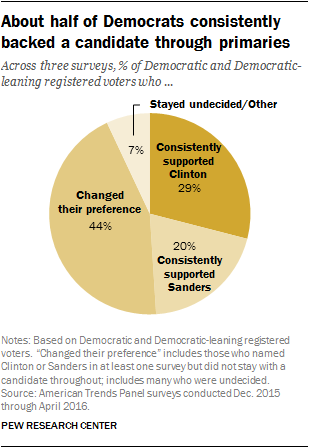Highlight a few significant elements in this photo. The percentage value of the smallest segment is 7. 